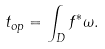<formula> <loc_0><loc_0><loc_500><loc_500>t _ { o p } = \int _ { D } f ^ { * } \omega .</formula> 